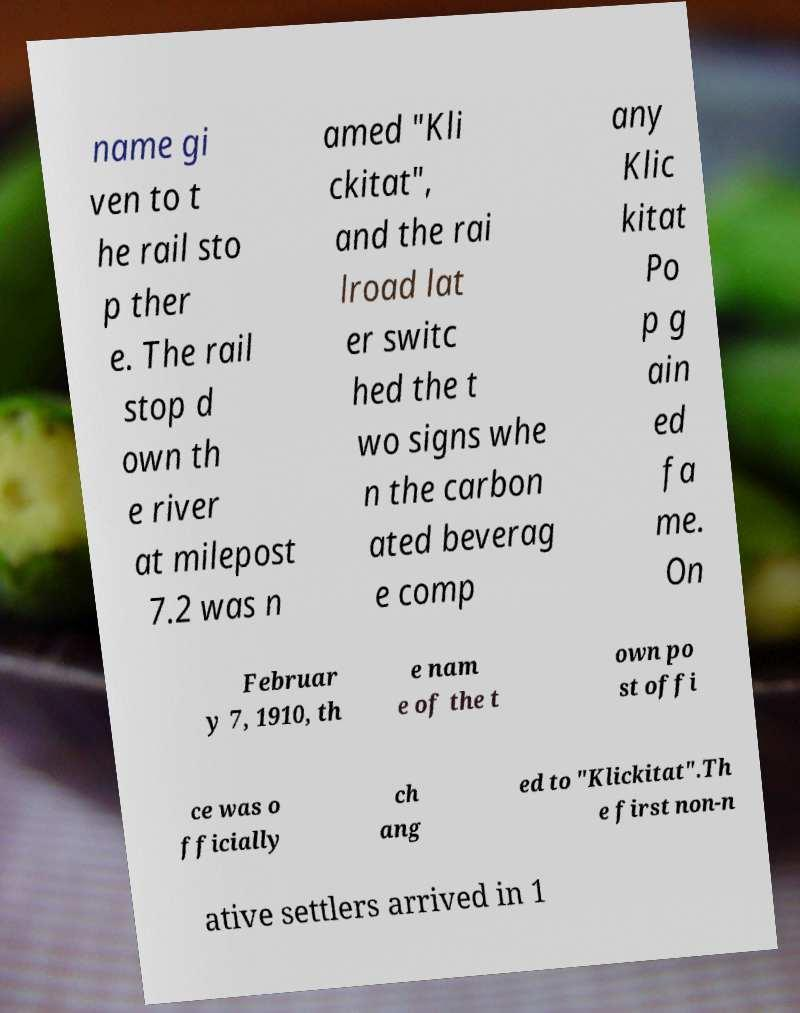For documentation purposes, I need the text within this image transcribed. Could you provide that? name gi ven to t he rail sto p ther e. The rail stop d own th e river at milepost 7.2 was n amed "Kli ckitat", and the rai lroad lat er switc hed the t wo signs whe n the carbon ated beverag e comp any Klic kitat Po p g ain ed fa me. On Februar y 7, 1910, th e nam e of the t own po st offi ce was o fficially ch ang ed to "Klickitat".Th e first non-n ative settlers arrived in 1 